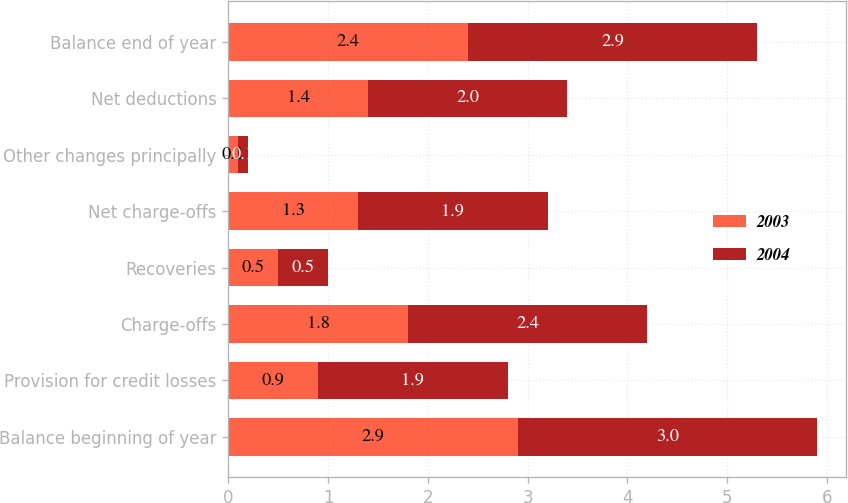Convert chart to OTSL. <chart><loc_0><loc_0><loc_500><loc_500><stacked_bar_chart><ecel><fcel>Balance beginning of year<fcel>Provision for credit losses<fcel>Charge-offs<fcel>Recoveries<fcel>Net charge-offs<fcel>Other changes principally<fcel>Net deductions<fcel>Balance end of year<nl><fcel>2003<fcel>2.9<fcel>0.9<fcel>1.8<fcel>0.5<fcel>1.3<fcel>0.1<fcel>1.4<fcel>2.4<nl><fcel>2004<fcel>3<fcel>1.9<fcel>2.4<fcel>0.5<fcel>1.9<fcel>0.1<fcel>2<fcel>2.9<nl></chart> 